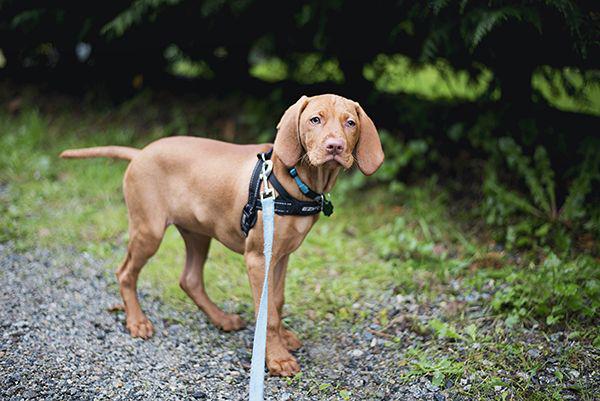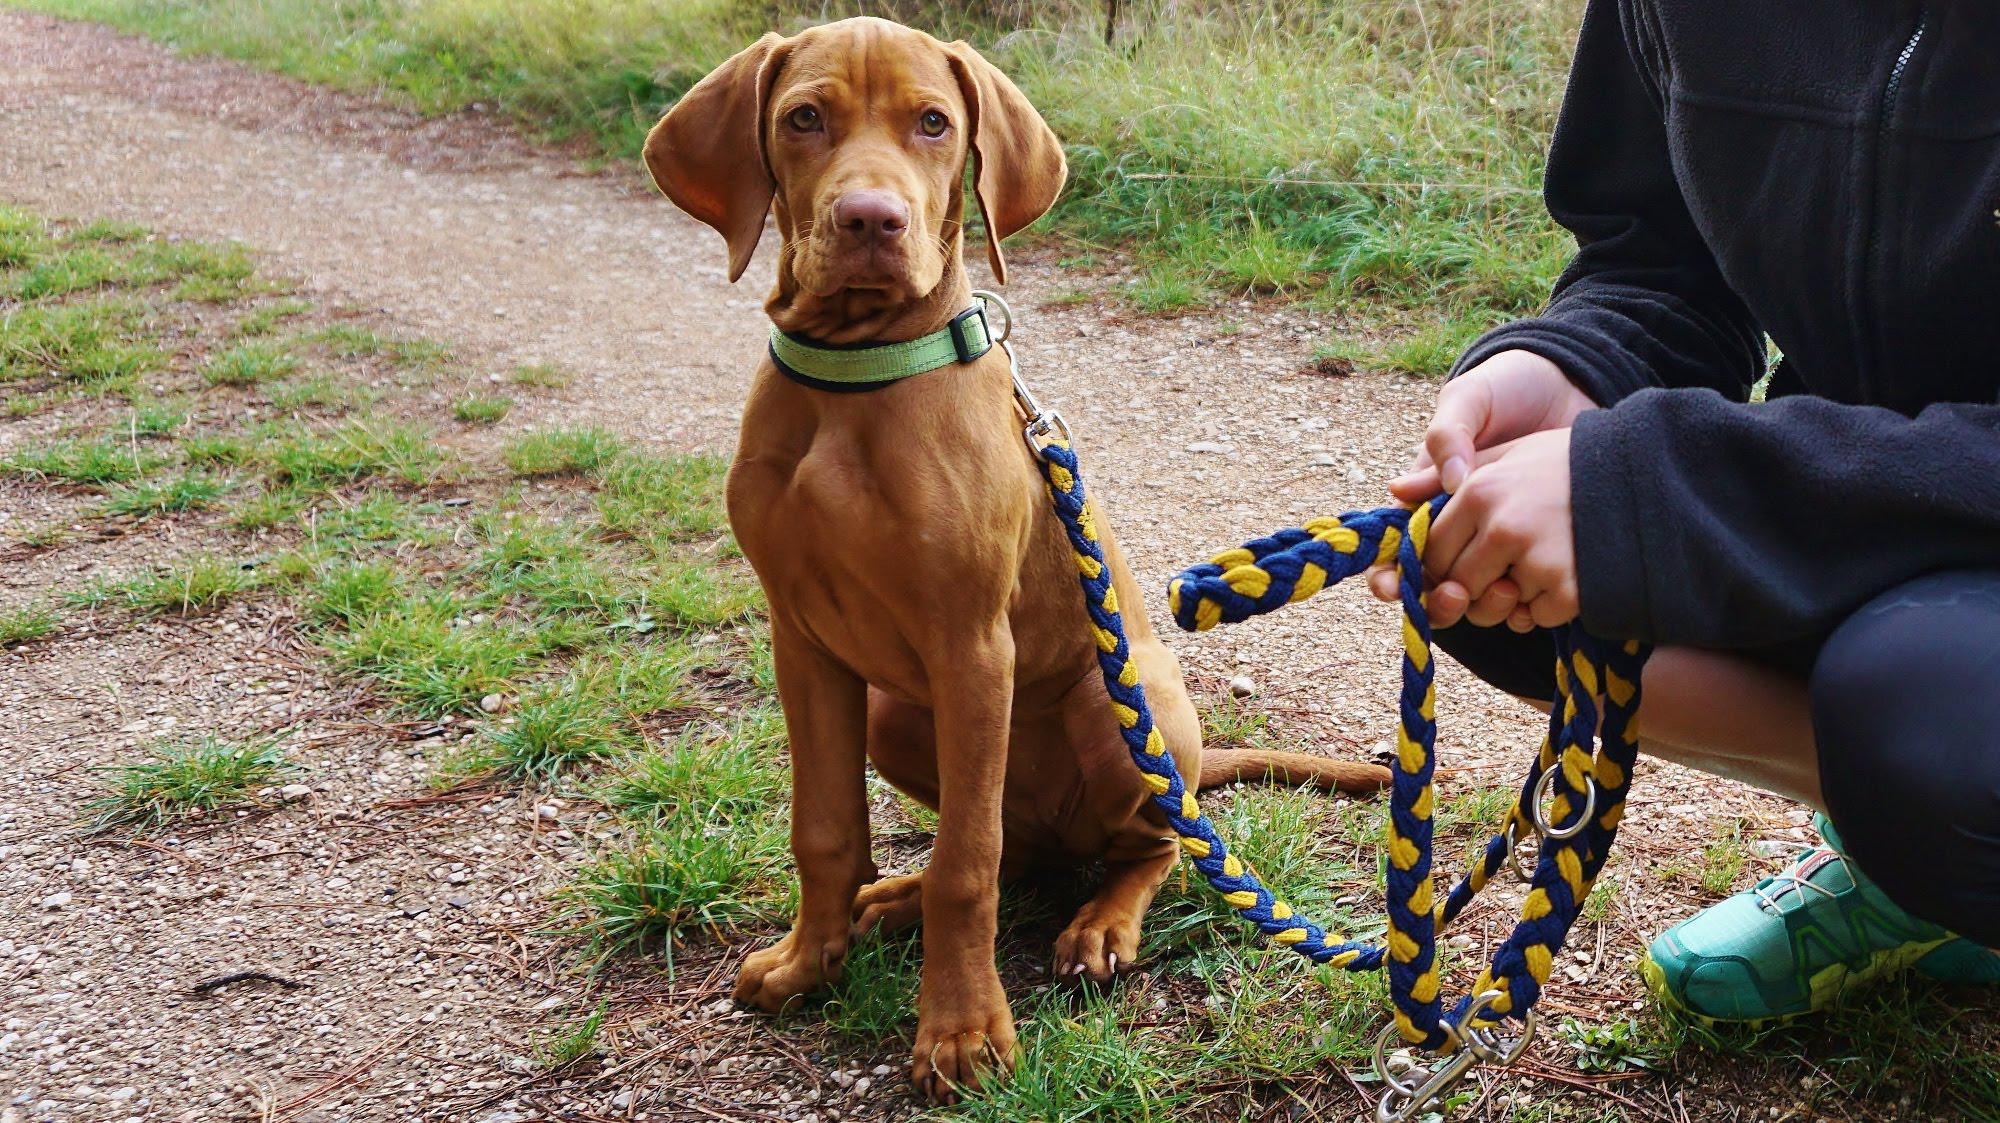The first image is the image on the left, the second image is the image on the right. Examine the images to the left and right. Is the description "IN at least one image there is a collared dog sitting straight forward." accurate? Answer yes or no. Yes. 